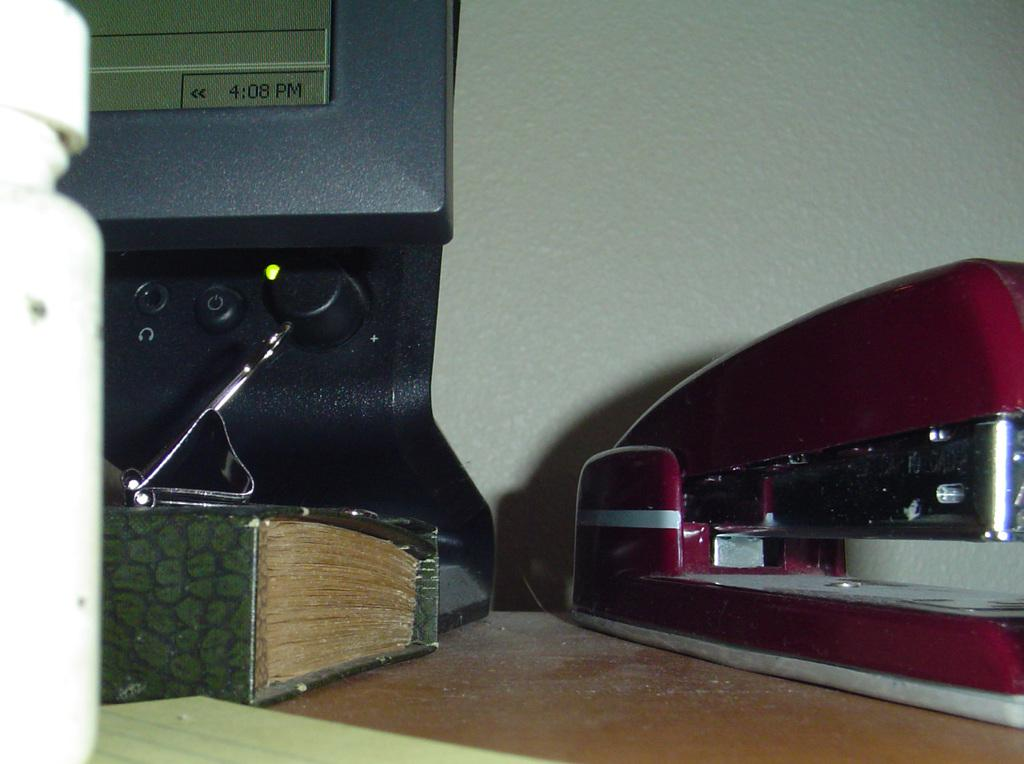What electronic device is visible in the image? There is a monitor in the image. What type of item can be seen besides the monitor? There is a book in the image. What is the surface on which the monitor and book are placed? The monitor and book are on a table in the image. Can you describe any other objects on the table? There are other objects on the table in the image, but their specific details are not mentioned in the provided facts. What type of juice is being poured from the cord in the image? There is no juice or cord present in the image. What type of apparel is being worn by the person in the image? There is no person or apparel mentioned in the provided facts, so we cannot answer this question. 